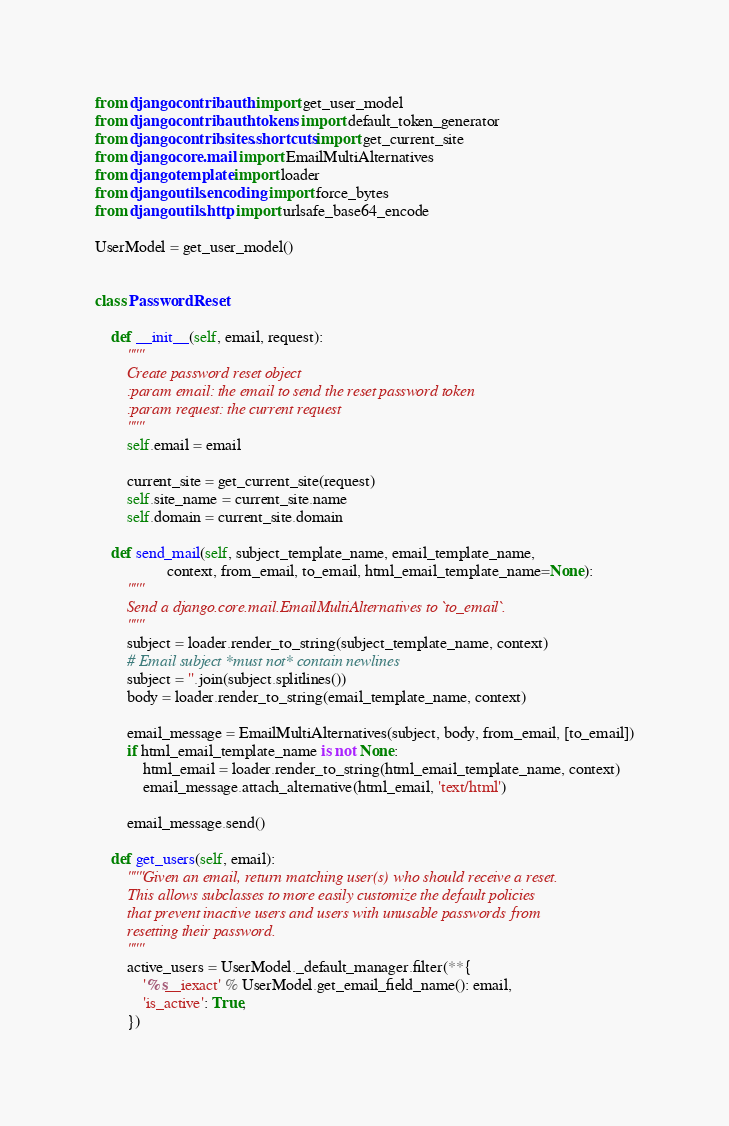Convert code to text. <code><loc_0><loc_0><loc_500><loc_500><_Python_>from django.contrib.auth import get_user_model
from django.contrib.auth.tokens import default_token_generator
from django.contrib.sites.shortcuts import get_current_site
from django.core.mail import EmailMultiAlternatives
from django.template import loader
from django.utils.encoding import force_bytes
from django.utils.http import urlsafe_base64_encode

UserModel = get_user_model()


class PasswordReset:

    def __init__(self, email, request):
        """
        Create password reset object
        :param email: the email to send the reset password token
        :param request: the current request
        """
        self.email = email

        current_site = get_current_site(request)
        self.site_name = current_site.name
        self.domain = current_site.domain

    def send_mail(self, subject_template_name, email_template_name,
                  context, from_email, to_email, html_email_template_name=None):
        """
        Send a django.core.mail.EmailMultiAlternatives to `to_email`.
        """
        subject = loader.render_to_string(subject_template_name, context)
        # Email subject *must not* contain newlines
        subject = ''.join(subject.splitlines())
        body = loader.render_to_string(email_template_name, context)

        email_message = EmailMultiAlternatives(subject, body, from_email, [to_email])
        if html_email_template_name is not None:
            html_email = loader.render_to_string(html_email_template_name, context)
            email_message.attach_alternative(html_email, 'text/html')

        email_message.send()

    def get_users(self, email):
        """Given an email, return matching user(s) who should receive a reset.
        This allows subclasses to more easily customize the default policies
        that prevent inactive users and users with unusable passwords from
        resetting their password.
        """
        active_users = UserModel._default_manager.filter(**{
            '%s__iexact' % UserModel.get_email_field_name(): email,
            'is_active': True,
        })</code> 